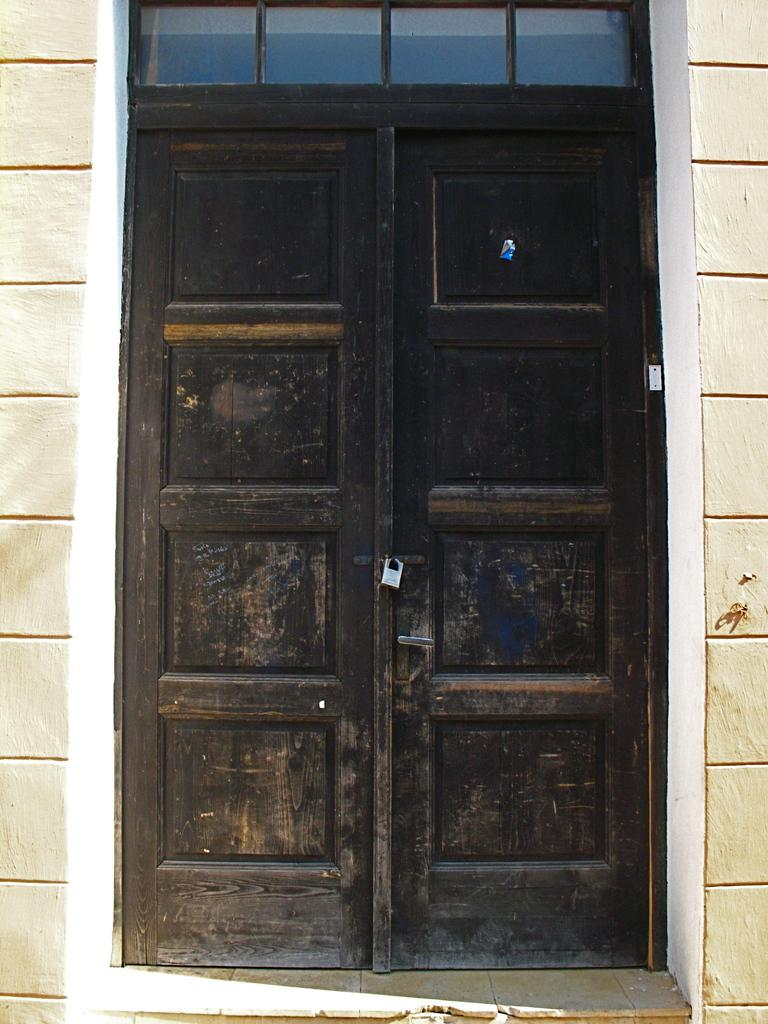What is the status of the doors in the image? The doors in the image are locked. What can be seen in the background of the image? There is a wall visible in the background of the image. What type of pickle is being used to express anger in the image? There is no pickle or expression of anger present in the image. 